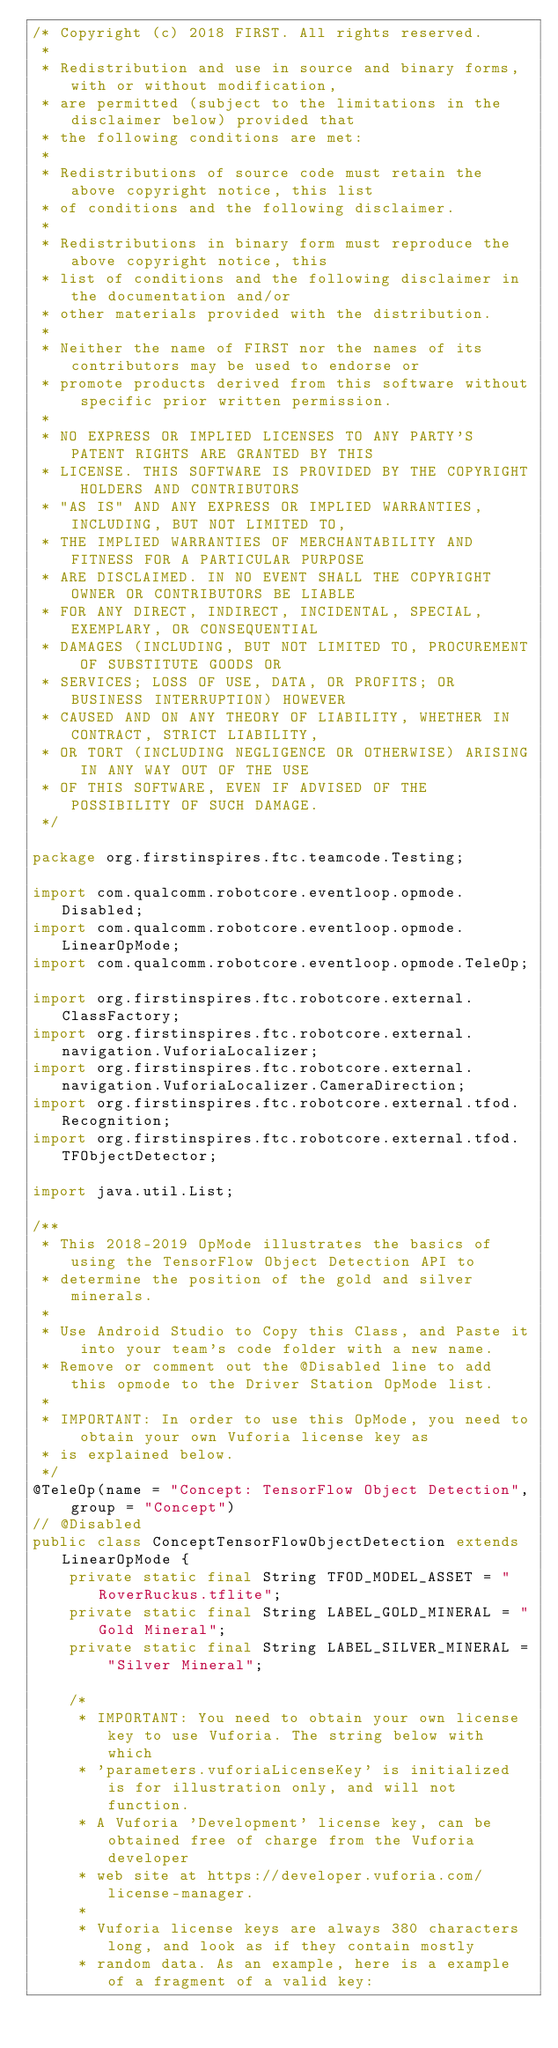Convert code to text. <code><loc_0><loc_0><loc_500><loc_500><_Java_>/* Copyright (c) 2018 FIRST. All rights reserved.
 *
 * Redistribution and use in source and binary forms, with or without modification,
 * are permitted (subject to the limitations in the disclaimer below) provided that
 * the following conditions are met:
 *
 * Redistributions of source code must retain the above copyright notice, this list
 * of conditions and the following disclaimer.
 *
 * Redistributions in binary form must reproduce the above copyright notice, this
 * list of conditions and the following disclaimer in the documentation and/or
 * other materials provided with the distribution.
 *
 * Neither the name of FIRST nor the names of its contributors may be used to endorse or
 * promote products derived from this software without specific prior written permission.
 *
 * NO EXPRESS OR IMPLIED LICENSES TO ANY PARTY'S PATENT RIGHTS ARE GRANTED BY THIS
 * LICENSE. THIS SOFTWARE IS PROVIDED BY THE COPYRIGHT HOLDERS AND CONTRIBUTORS
 * "AS IS" AND ANY EXPRESS OR IMPLIED WARRANTIES, INCLUDING, BUT NOT LIMITED TO,
 * THE IMPLIED WARRANTIES OF MERCHANTABILITY AND FITNESS FOR A PARTICULAR PURPOSE
 * ARE DISCLAIMED. IN NO EVENT SHALL THE COPYRIGHT OWNER OR CONTRIBUTORS BE LIABLE
 * FOR ANY DIRECT, INDIRECT, INCIDENTAL, SPECIAL, EXEMPLARY, OR CONSEQUENTIAL
 * DAMAGES (INCLUDING, BUT NOT LIMITED TO, PROCUREMENT OF SUBSTITUTE GOODS OR
 * SERVICES; LOSS OF USE, DATA, OR PROFITS; OR BUSINESS INTERRUPTION) HOWEVER
 * CAUSED AND ON ANY THEORY OF LIABILITY, WHETHER IN CONTRACT, STRICT LIABILITY,
 * OR TORT (INCLUDING NEGLIGENCE OR OTHERWISE) ARISING IN ANY WAY OUT OF THE USE
 * OF THIS SOFTWARE, EVEN IF ADVISED OF THE POSSIBILITY OF SUCH DAMAGE.
 */

package org.firstinspires.ftc.teamcode.Testing;

import com.qualcomm.robotcore.eventloop.opmode.Disabled;
import com.qualcomm.robotcore.eventloop.opmode.LinearOpMode;
import com.qualcomm.robotcore.eventloop.opmode.TeleOp;

import org.firstinspires.ftc.robotcore.external.ClassFactory;
import org.firstinspires.ftc.robotcore.external.navigation.VuforiaLocalizer;
import org.firstinspires.ftc.robotcore.external.navigation.VuforiaLocalizer.CameraDirection;
import org.firstinspires.ftc.robotcore.external.tfod.Recognition;
import org.firstinspires.ftc.robotcore.external.tfod.TFObjectDetector;

import java.util.List;

/**
 * This 2018-2019 OpMode illustrates the basics of using the TensorFlow Object Detection API to
 * determine the position of the gold and silver minerals.
 *
 * Use Android Studio to Copy this Class, and Paste it into your team's code folder with a new name.
 * Remove or comment out the @Disabled line to add this opmode to the Driver Station OpMode list.
 *
 * IMPORTANT: In order to use this OpMode, you need to obtain your own Vuforia license key as
 * is explained below.
 */
@TeleOp(name = "Concept: TensorFlow Object Detection", group = "Concept")
// @Disabled
public class ConceptTensorFlowObjectDetection extends LinearOpMode {
    private static final String TFOD_MODEL_ASSET = "RoverRuckus.tflite";
    private static final String LABEL_GOLD_MINERAL = "Gold Mineral";
    private static final String LABEL_SILVER_MINERAL = "Silver Mineral";

    /*
     * IMPORTANT: You need to obtain your own license key to use Vuforia. The string below with which
     * 'parameters.vuforiaLicenseKey' is initialized is for illustration only, and will not function.
     * A Vuforia 'Development' license key, can be obtained free of charge from the Vuforia developer
     * web site at https://developer.vuforia.com/license-manager.
     *
     * Vuforia license keys are always 380 characters long, and look as if they contain mostly
     * random data. As an example, here is a example of a fragment of a valid key:</code> 